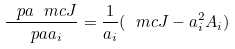Convert formula to latex. <formula><loc_0><loc_0><loc_500><loc_500>\frac { \ p a \ m c J } { \ p a a _ { i } } = \frac { 1 } { a _ { i } } ( \ m c J - a _ { i } ^ { 2 } A _ { i } )</formula> 